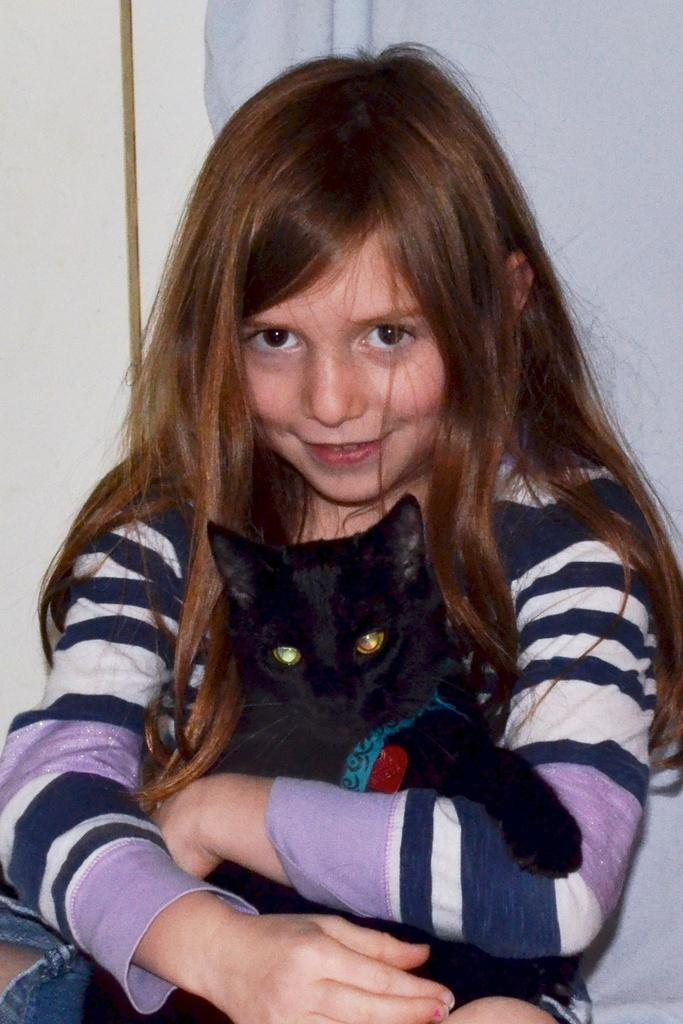What is the main subject of the image? The main subject of the image is a baby girl. What is the baby girl holding in the image? The baby girl is holding a cat. What is the baby girl's facial expression in the image? The baby girl is smiling. What type of lumber is the baby girl using to fuel the fire in the image? There is no lumber or fire present in the image; it features a baby girl holding a cat and smiling. Who is the baby girl's aunt in the image? There is no mention of an aunt in the image; it only shows a baby girl holding a cat and smiling. 